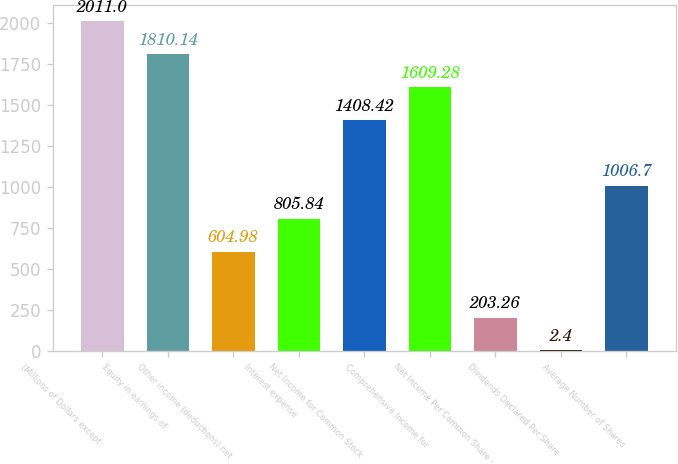Convert chart to OTSL. <chart><loc_0><loc_0><loc_500><loc_500><bar_chart><fcel>(Millions of Dollars except<fcel>Equity in earnings of<fcel>Other income (deductions) net<fcel>Interest expense<fcel>Net Income for Common Stock<fcel>Comprehensive Income for<fcel>Net Income Per Common Share -<fcel>Dividends Declared Per Share<fcel>Average Number of Shares<nl><fcel>2011<fcel>1810.14<fcel>604.98<fcel>805.84<fcel>1408.42<fcel>1609.28<fcel>203.26<fcel>2.4<fcel>1006.7<nl></chart> 